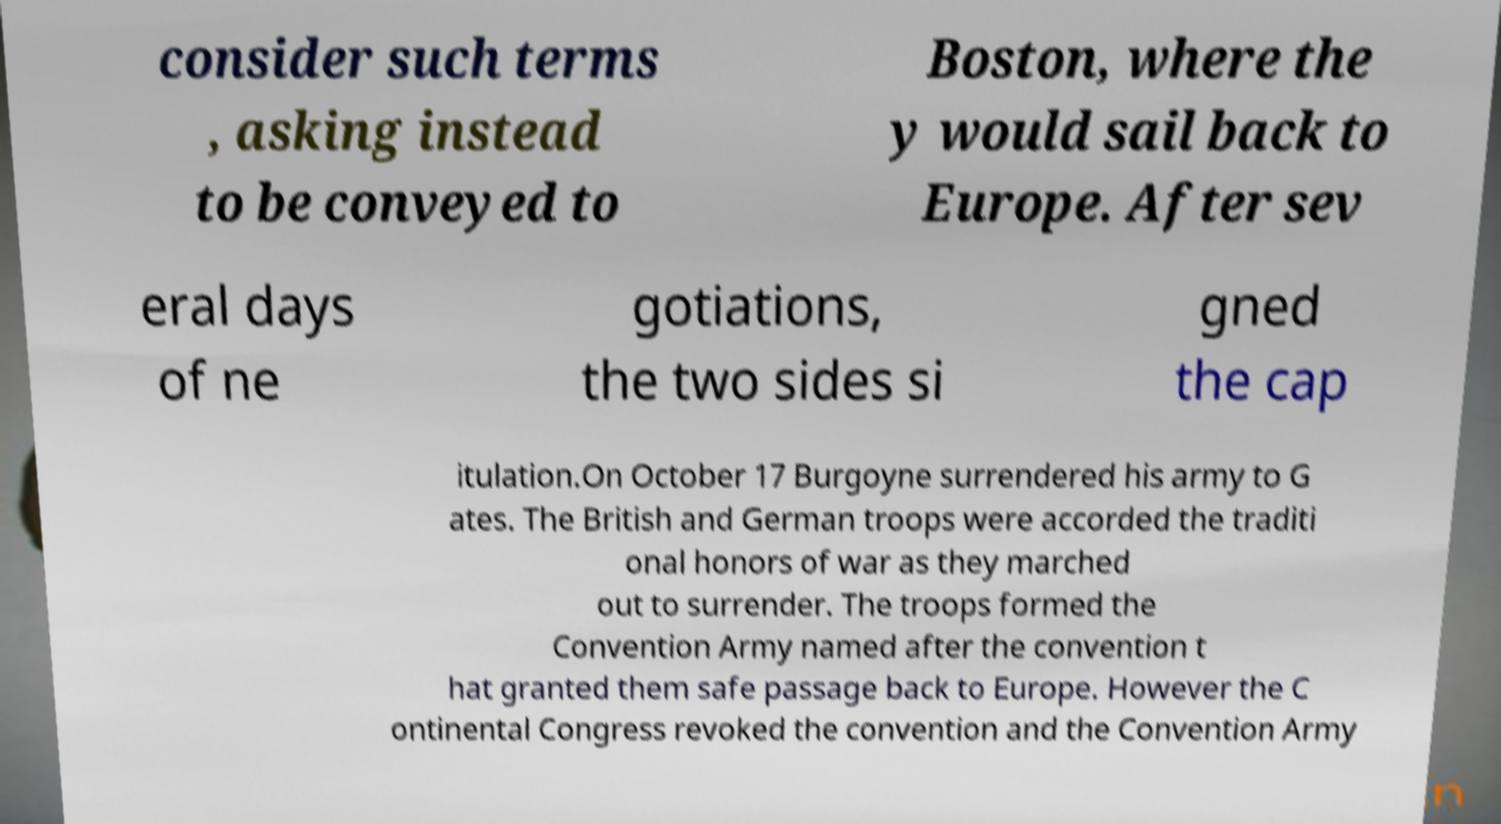For documentation purposes, I need the text within this image transcribed. Could you provide that? consider such terms , asking instead to be conveyed to Boston, where the y would sail back to Europe. After sev eral days of ne gotiations, the two sides si gned the cap itulation.On October 17 Burgoyne surrendered his army to G ates. The British and German troops were accorded the traditi onal honors of war as they marched out to surrender. The troops formed the Convention Army named after the convention t hat granted them safe passage back to Europe. However the C ontinental Congress revoked the convention and the Convention Army 